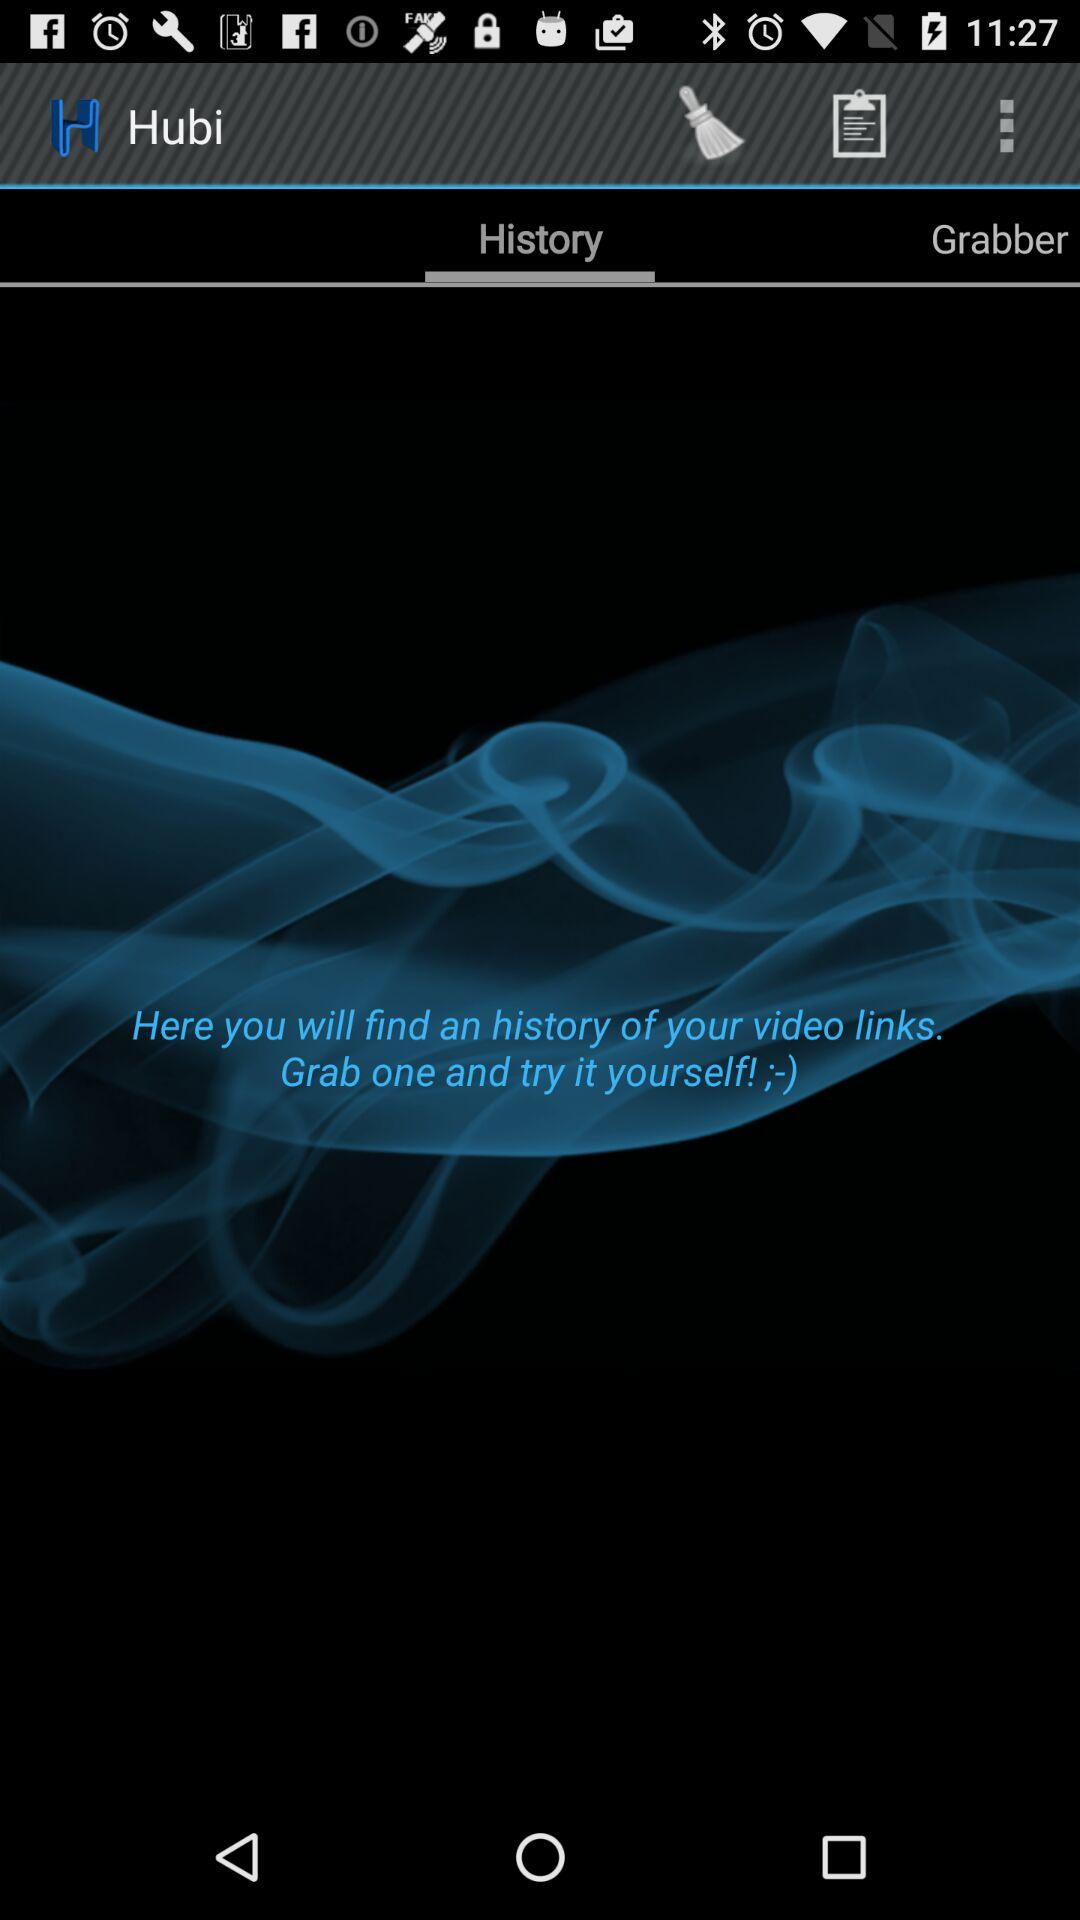What is the name of the application? The name of the application is "Hubi". 